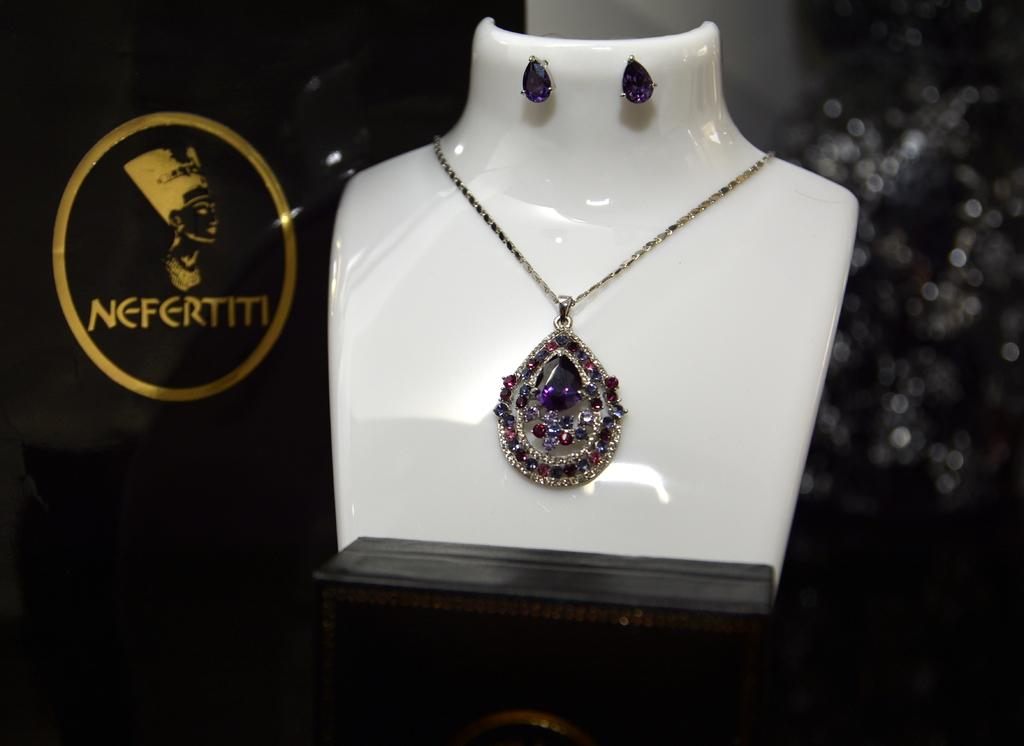What is the main subject of the image? There is a necklace in the image. Are there any other objects present in the image? Yes, there are other objects in the image. What is the color of the object on which the necklace and other objects are placed? The objects are on a white color object. How would you describe the background of the image? The background of the image is dark and blurred. What type of brass instrument is being played in the background of the image? There is no brass instrument or any indication of music being played in the image. 